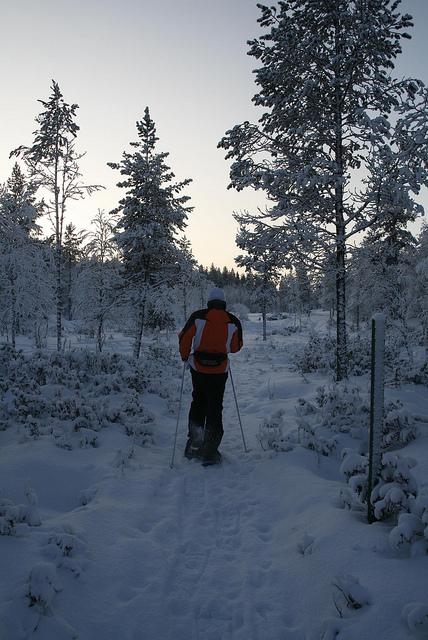What time of day is it?
Give a very brief answer. Evening. What color are his pants?
Short answer required. Black. Is this man skiing?
Short answer required. Yes. What on the person carrying on his back?
Quick response, please. Backpack. 